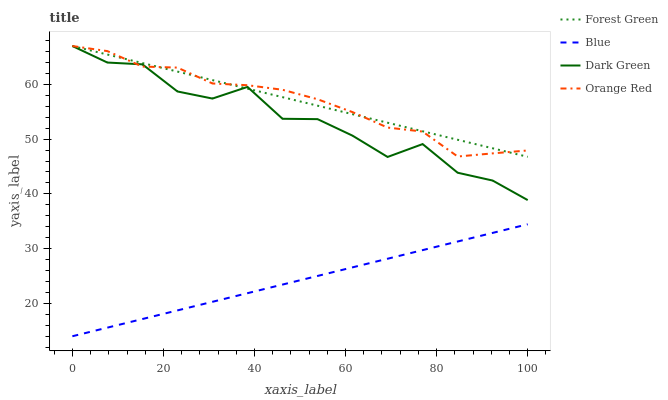Does Blue have the minimum area under the curve?
Answer yes or no. Yes. Does Forest Green have the maximum area under the curve?
Answer yes or no. Yes. Does Orange Red have the minimum area under the curve?
Answer yes or no. No. Does Orange Red have the maximum area under the curve?
Answer yes or no. No. Is Blue the smoothest?
Answer yes or no. Yes. Is Dark Green the roughest?
Answer yes or no. Yes. Is Forest Green the smoothest?
Answer yes or no. No. Is Forest Green the roughest?
Answer yes or no. No. Does Blue have the lowest value?
Answer yes or no. Yes. Does Forest Green have the lowest value?
Answer yes or no. No. Does Dark Green have the highest value?
Answer yes or no. Yes. Is Blue less than Forest Green?
Answer yes or no. Yes. Is Dark Green greater than Blue?
Answer yes or no. Yes. Does Dark Green intersect Forest Green?
Answer yes or no. Yes. Is Dark Green less than Forest Green?
Answer yes or no. No. Is Dark Green greater than Forest Green?
Answer yes or no. No. Does Blue intersect Forest Green?
Answer yes or no. No. 